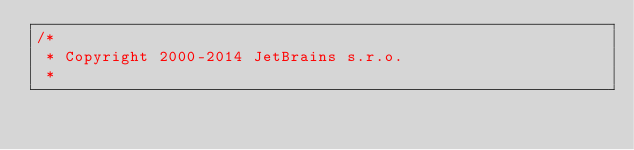Convert code to text. <code><loc_0><loc_0><loc_500><loc_500><_Java_>/*
 * Copyright 2000-2014 JetBrains s.r.o.
 *</code> 